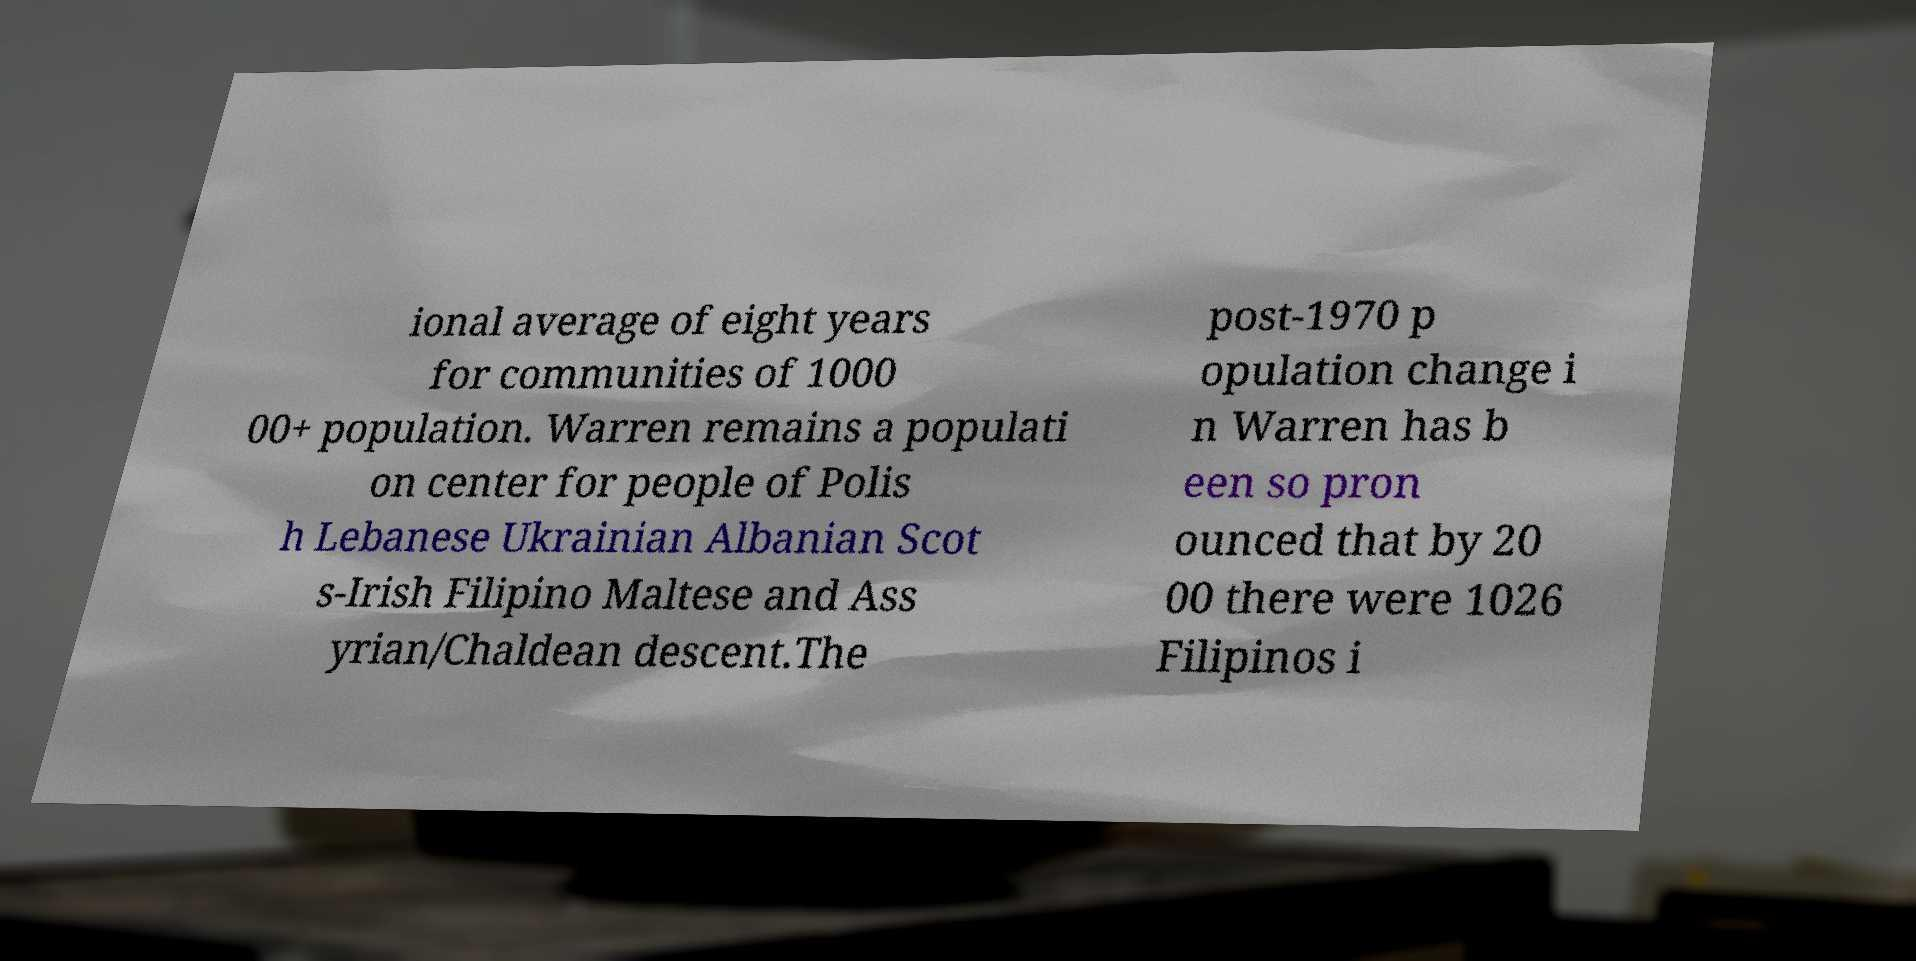Please identify and transcribe the text found in this image. ional average of eight years for communities of 1000 00+ population. Warren remains a populati on center for people of Polis h Lebanese Ukrainian Albanian Scot s-Irish Filipino Maltese and Ass yrian/Chaldean descent.The post-1970 p opulation change i n Warren has b een so pron ounced that by 20 00 there were 1026 Filipinos i 